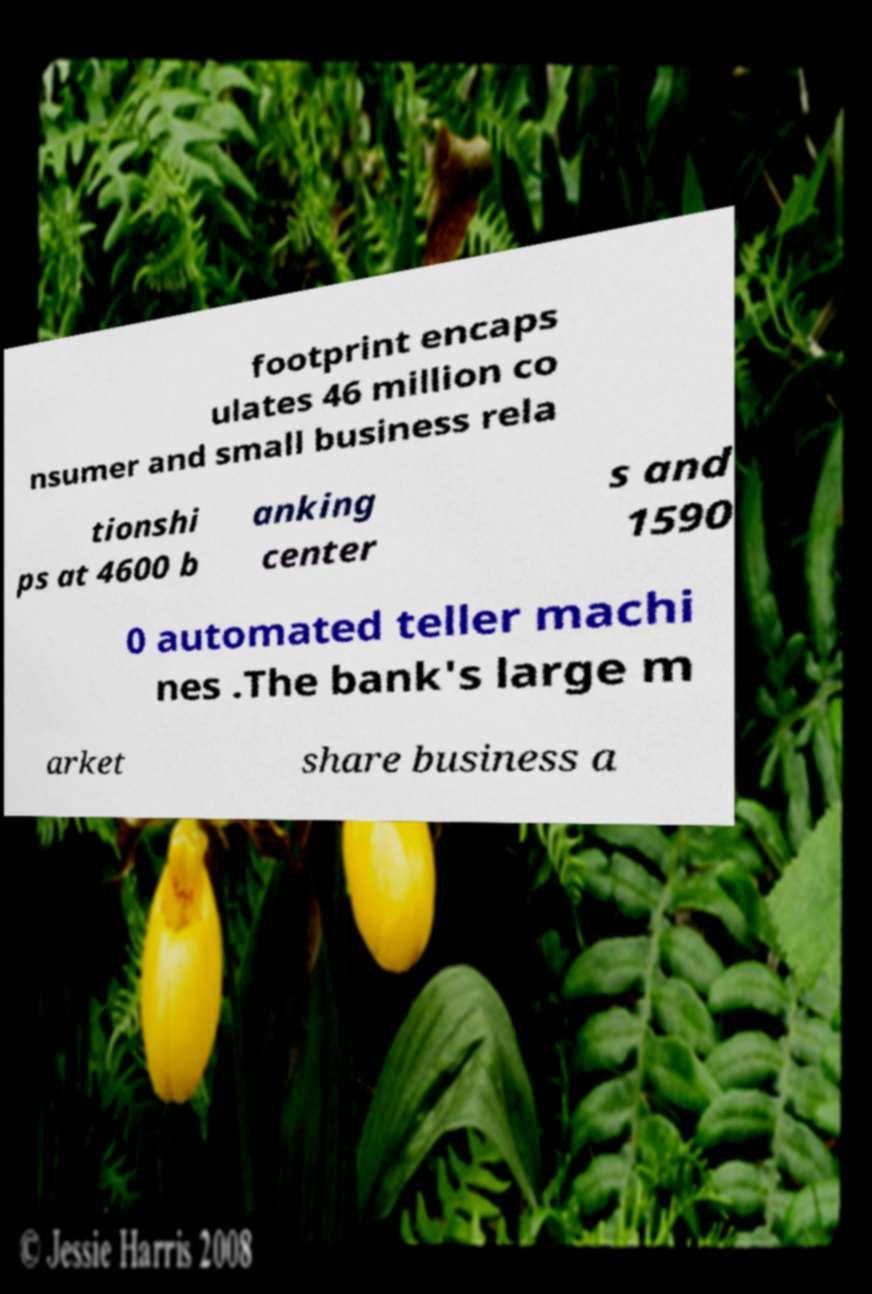Can you read and provide the text displayed in the image?This photo seems to have some interesting text. Can you extract and type it out for me? footprint encaps ulates 46 million co nsumer and small business rela tionshi ps at 4600 b anking center s and 1590 0 automated teller machi nes .The bank's large m arket share business a 